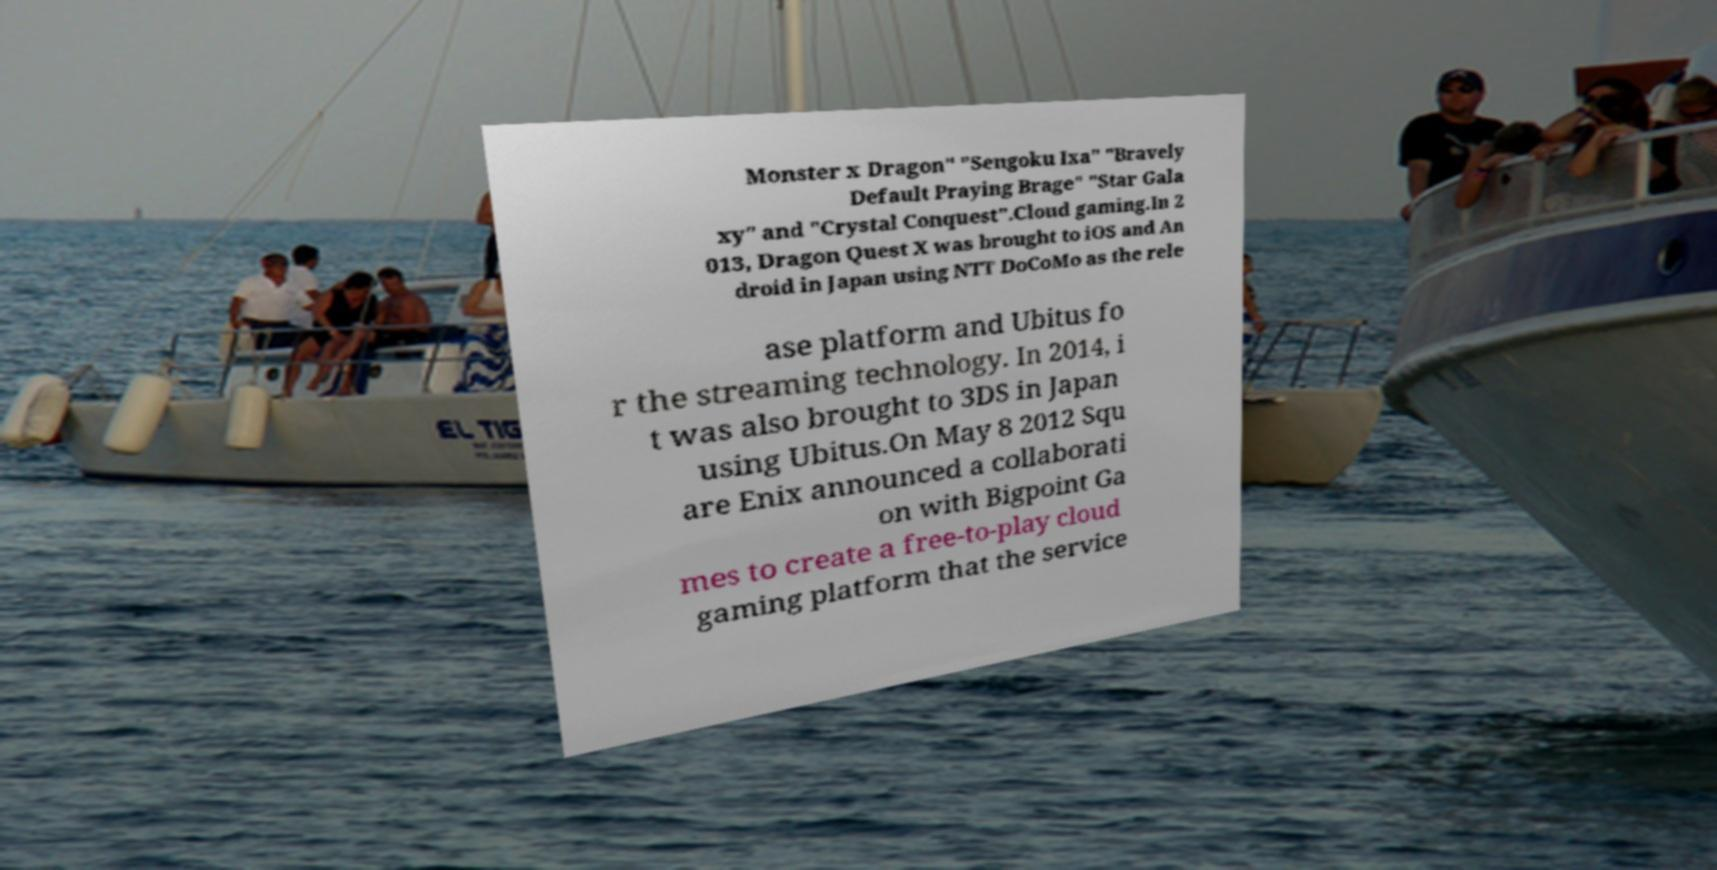Could you extract and type out the text from this image? Monster x Dragon" "Sengoku Ixa" "Bravely Default Praying Brage" "Star Gala xy" and "Crystal Conquest".Cloud gaming.In 2 013, Dragon Quest X was brought to iOS and An droid in Japan using NTT DoCoMo as the rele ase platform and Ubitus fo r the streaming technology. In 2014, i t was also brought to 3DS in Japan using Ubitus.On May 8 2012 Squ are Enix announced a collaborati on with Bigpoint Ga mes to create a free-to-play cloud gaming platform that the service 